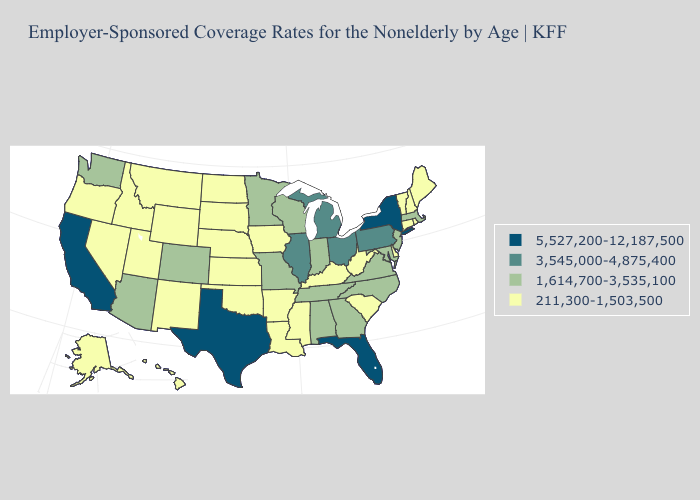Name the states that have a value in the range 211,300-1,503,500?
Write a very short answer. Alaska, Arkansas, Connecticut, Delaware, Hawaii, Idaho, Iowa, Kansas, Kentucky, Louisiana, Maine, Mississippi, Montana, Nebraska, Nevada, New Hampshire, New Mexico, North Dakota, Oklahoma, Oregon, Rhode Island, South Carolina, South Dakota, Utah, Vermont, West Virginia, Wyoming. What is the highest value in the South ?
Short answer required. 5,527,200-12,187,500. Name the states that have a value in the range 5,527,200-12,187,500?
Short answer required. California, Florida, New York, Texas. Which states hav the highest value in the South?
Be succinct. Florida, Texas. Does the map have missing data?
Give a very brief answer. No. Does Montana have a lower value than Mississippi?
Concise answer only. No. Does Virginia have the lowest value in the South?
Be succinct. No. What is the value of Oklahoma?
Keep it brief. 211,300-1,503,500. Name the states that have a value in the range 5,527,200-12,187,500?
Concise answer only. California, Florida, New York, Texas. What is the value of West Virginia?
Concise answer only. 211,300-1,503,500. Does Illinois have a higher value than Texas?
Concise answer only. No. Name the states that have a value in the range 3,545,000-4,875,400?
Keep it brief. Illinois, Michigan, Ohio, Pennsylvania. Is the legend a continuous bar?
Give a very brief answer. No. Among the states that border Missouri , does Tennessee have the lowest value?
Quick response, please. No. Name the states that have a value in the range 1,614,700-3,535,100?
Give a very brief answer. Alabama, Arizona, Colorado, Georgia, Indiana, Maryland, Massachusetts, Minnesota, Missouri, New Jersey, North Carolina, Tennessee, Virginia, Washington, Wisconsin. 